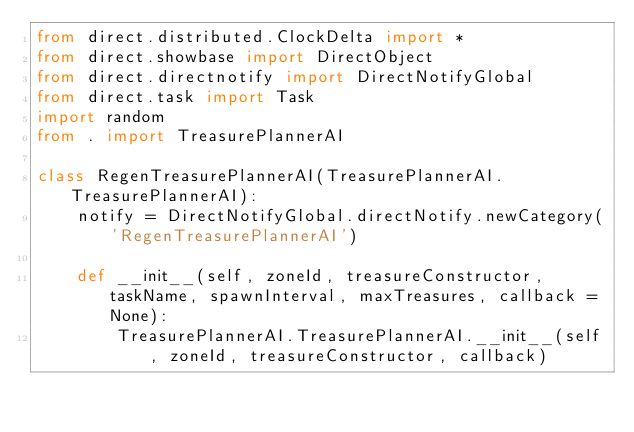Convert code to text. <code><loc_0><loc_0><loc_500><loc_500><_Python_>from direct.distributed.ClockDelta import *
from direct.showbase import DirectObject
from direct.directnotify import DirectNotifyGlobal
from direct.task import Task
import random
from . import TreasurePlannerAI

class RegenTreasurePlannerAI(TreasurePlannerAI.TreasurePlannerAI):
    notify = DirectNotifyGlobal.directNotify.newCategory('RegenTreasurePlannerAI')

    def __init__(self, zoneId, treasureConstructor, taskName, spawnInterval, maxTreasures, callback = None):
        TreasurePlannerAI.TreasurePlannerAI.__init__(self, zoneId, treasureConstructor, callback)</code> 